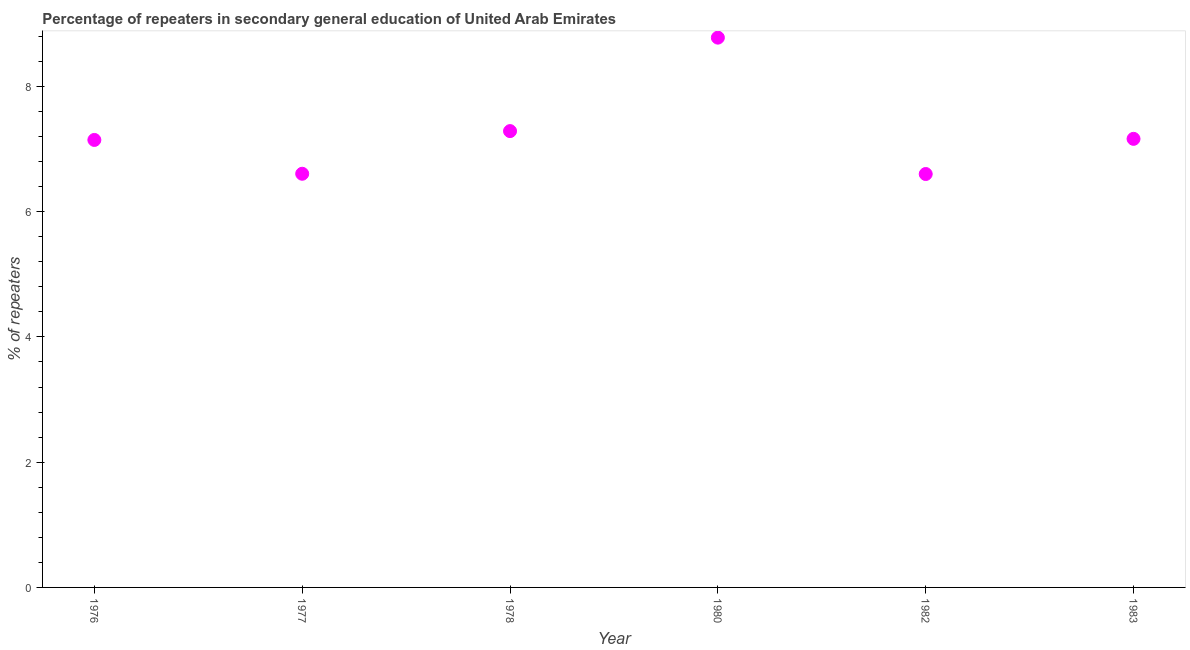What is the percentage of repeaters in 1978?
Offer a very short reply. 7.29. Across all years, what is the maximum percentage of repeaters?
Your answer should be compact. 8.78. Across all years, what is the minimum percentage of repeaters?
Your answer should be compact. 6.6. What is the sum of the percentage of repeaters?
Make the answer very short. 43.58. What is the difference between the percentage of repeaters in 1982 and 1983?
Provide a short and direct response. -0.56. What is the average percentage of repeaters per year?
Offer a terse response. 7.26. What is the median percentage of repeaters?
Offer a very short reply. 7.15. Do a majority of the years between 1982 and 1976 (inclusive) have percentage of repeaters greater than 8 %?
Provide a short and direct response. Yes. What is the ratio of the percentage of repeaters in 1976 to that in 1977?
Your response must be concise. 1.08. Is the percentage of repeaters in 1982 less than that in 1983?
Offer a terse response. Yes. Is the difference between the percentage of repeaters in 1976 and 1980 greater than the difference between any two years?
Your answer should be compact. No. What is the difference between the highest and the second highest percentage of repeaters?
Make the answer very short. 1.49. What is the difference between the highest and the lowest percentage of repeaters?
Your answer should be compact. 2.18. In how many years, is the percentage of repeaters greater than the average percentage of repeaters taken over all years?
Offer a very short reply. 2. How many dotlines are there?
Your answer should be compact. 1. What is the difference between two consecutive major ticks on the Y-axis?
Keep it short and to the point. 2. Are the values on the major ticks of Y-axis written in scientific E-notation?
Your answer should be compact. No. Does the graph contain any zero values?
Your answer should be compact. No. What is the title of the graph?
Your answer should be very brief. Percentage of repeaters in secondary general education of United Arab Emirates. What is the label or title of the X-axis?
Offer a very short reply. Year. What is the label or title of the Y-axis?
Make the answer very short. % of repeaters. What is the % of repeaters in 1976?
Provide a short and direct response. 7.15. What is the % of repeaters in 1977?
Provide a short and direct response. 6.61. What is the % of repeaters in 1978?
Keep it short and to the point. 7.29. What is the % of repeaters in 1980?
Give a very brief answer. 8.78. What is the % of repeaters in 1982?
Keep it short and to the point. 6.6. What is the % of repeaters in 1983?
Provide a succinct answer. 7.16. What is the difference between the % of repeaters in 1976 and 1977?
Provide a short and direct response. 0.54. What is the difference between the % of repeaters in 1976 and 1978?
Provide a succinct answer. -0.14. What is the difference between the % of repeaters in 1976 and 1980?
Make the answer very short. -1.63. What is the difference between the % of repeaters in 1976 and 1982?
Give a very brief answer. 0.54. What is the difference between the % of repeaters in 1976 and 1983?
Give a very brief answer. -0.02. What is the difference between the % of repeaters in 1977 and 1978?
Offer a very short reply. -0.68. What is the difference between the % of repeaters in 1977 and 1980?
Provide a succinct answer. -2.17. What is the difference between the % of repeaters in 1977 and 1982?
Keep it short and to the point. 0. What is the difference between the % of repeaters in 1977 and 1983?
Your response must be concise. -0.56. What is the difference between the % of repeaters in 1978 and 1980?
Make the answer very short. -1.49. What is the difference between the % of repeaters in 1978 and 1982?
Offer a terse response. 0.69. What is the difference between the % of repeaters in 1978 and 1983?
Your answer should be very brief. 0.12. What is the difference between the % of repeaters in 1980 and 1982?
Give a very brief answer. 2.18. What is the difference between the % of repeaters in 1980 and 1983?
Offer a terse response. 1.62. What is the difference between the % of repeaters in 1982 and 1983?
Provide a short and direct response. -0.56. What is the ratio of the % of repeaters in 1976 to that in 1977?
Offer a terse response. 1.08. What is the ratio of the % of repeaters in 1976 to that in 1978?
Your response must be concise. 0.98. What is the ratio of the % of repeaters in 1976 to that in 1980?
Keep it short and to the point. 0.81. What is the ratio of the % of repeaters in 1976 to that in 1982?
Keep it short and to the point. 1.08. What is the ratio of the % of repeaters in 1976 to that in 1983?
Make the answer very short. 1. What is the ratio of the % of repeaters in 1977 to that in 1978?
Your response must be concise. 0.91. What is the ratio of the % of repeaters in 1977 to that in 1980?
Provide a succinct answer. 0.75. What is the ratio of the % of repeaters in 1977 to that in 1983?
Offer a terse response. 0.92. What is the ratio of the % of repeaters in 1978 to that in 1980?
Provide a short and direct response. 0.83. What is the ratio of the % of repeaters in 1978 to that in 1982?
Your response must be concise. 1.1. What is the ratio of the % of repeaters in 1980 to that in 1982?
Offer a terse response. 1.33. What is the ratio of the % of repeaters in 1980 to that in 1983?
Ensure brevity in your answer.  1.23. What is the ratio of the % of repeaters in 1982 to that in 1983?
Offer a terse response. 0.92. 